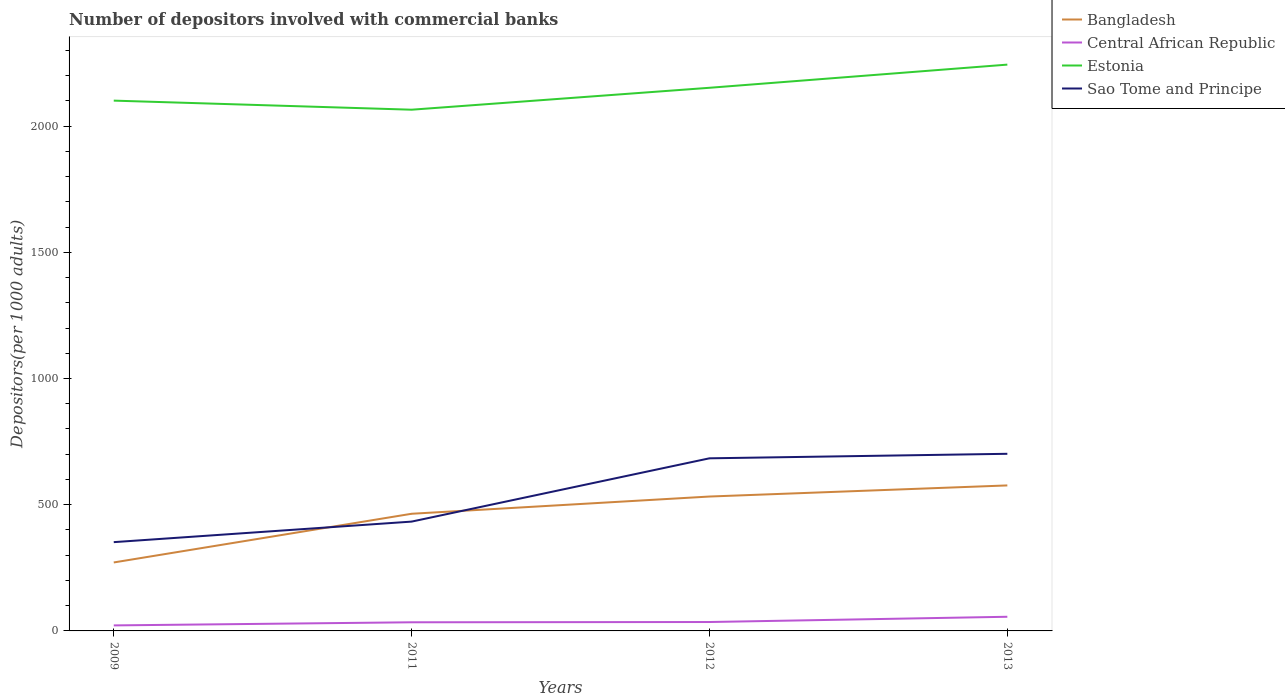How many different coloured lines are there?
Make the answer very short. 4. Does the line corresponding to Estonia intersect with the line corresponding to Bangladesh?
Provide a succinct answer. No. Is the number of lines equal to the number of legend labels?
Make the answer very short. Yes. Across all years, what is the maximum number of depositors involved with commercial banks in Central African Republic?
Your response must be concise. 21.85. In which year was the number of depositors involved with commercial banks in Estonia maximum?
Give a very brief answer. 2011. What is the total number of depositors involved with commercial banks in Bangladesh in the graph?
Offer a terse response. -43.98. What is the difference between the highest and the second highest number of depositors involved with commercial banks in Central African Republic?
Your answer should be very brief. 34.25. Is the number of depositors involved with commercial banks in Central African Republic strictly greater than the number of depositors involved with commercial banks in Sao Tome and Principe over the years?
Offer a very short reply. Yes. Does the graph contain any zero values?
Your answer should be very brief. No. Where does the legend appear in the graph?
Keep it short and to the point. Top right. What is the title of the graph?
Provide a short and direct response. Number of depositors involved with commercial banks. Does "Malta" appear as one of the legend labels in the graph?
Make the answer very short. No. What is the label or title of the X-axis?
Give a very brief answer. Years. What is the label or title of the Y-axis?
Keep it short and to the point. Depositors(per 1000 adults). What is the Depositors(per 1000 adults) in Bangladesh in 2009?
Give a very brief answer. 271.23. What is the Depositors(per 1000 adults) in Central African Republic in 2009?
Your answer should be very brief. 21.85. What is the Depositors(per 1000 adults) of Estonia in 2009?
Your answer should be compact. 2100.76. What is the Depositors(per 1000 adults) in Sao Tome and Principe in 2009?
Provide a short and direct response. 351.71. What is the Depositors(per 1000 adults) of Bangladesh in 2011?
Provide a short and direct response. 464.13. What is the Depositors(per 1000 adults) in Central African Republic in 2011?
Offer a terse response. 34.26. What is the Depositors(per 1000 adults) of Estonia in 2011?
Make the answer very short. 2064.84. What is the Depositors(per 1000 adults) in Sao Tome and Principe in 2011?
Ensure brevity in your answer.  433.08. What is the Depositors(per 1000 adults) in Bangladesh in 2012?
Make the answer very short. 532.4. What is the Depositors(per 1000 adults) of Central African Republic in 2012?
Give a very brief answer. 35.28. What is the Depositors(per 1000 adults) of Estonia in 2012?
Offer a very short reply. 2151.67. What is the Depositors(per 1000 adults) of Sao Tome and Principe in 2012?
Provide a short and direct response. 683.81. What is the Depositors(per 1000 adults) of Bangladesh in 2013?
Ensure brevity in your answer.  576.37. What is the Depositors(per 1000 adults) in Central African Republic in 2013?
Your answer should be very brief. 56.1. What is the Depositors(per 1000 adults) in Estonia in 2013?
Your response must be concise. 2243.44. What is the Depositors(per 1000 adults) of Sao Tome and Principe in 2013?
Provide a short and direct response. 701.7. Across all years, what is the maximum Depositors(per 1000 adults) of Bangladesh?
Provide a short and direct response. 576.37. Across all years, what is the maximum Depositors(per 1000 adults) in Central African Republic?
Your answer should be compact. 56.1. Across all years, what is the maximum Depositors(per 1000 adults) in Estonia?
Provide a succinct answer. 2243.44. Across all years, what is the maximum Depositors(per 1000 adults) in Sao Tome and Principe?
Your answer should be compact. 701.7. Across all years, what is the minimum Depositors(per 1000 adults) of Bangladesh?
Make the answer very short. 271.23. Across all years, what is the minimum Depositors(per 1000 adults) of Central African Republic?
Ensure brevity in your answer.  21.85. Across all years, what is the minimum Depositors(per 1000 adults) in Estonia?
Your answer should be compact. 2064.84. Across all years, what is the minimum Depositors(per 1000 adults) of Sao Tome and Principe?
Give a very brief answer. 351.71. What is the total Depositors(per 1000 adults) in Bangladesh in the graph?
Offer a very short reply. 1844.13. What is the total Depositors(per 1000 adults) in Central African Republic in the graph?
Ensure brevity in your answer.  147.48. What is the total Depositors(per 1000 adults) in Estonia in the graph?
Offer a very short reply. 8560.71. What is the total Depositors(per 1000 adults) of Sao Tome and Principe in the graph?
Your answer should be compact. 2170.3. What is the difference between the Depositors(per 1000 adults) in Bangladesh in 2009 and that in 2011?
Keep it short and to the point. -192.9. What is the difference between the Depositors(per 1000 adults) in Central African Republic in 2009 and that in 2011?
Offer a very short reply. -12.4. What is the difference between the Depositors(per 1000 adults) in Estonia in 2009 and that in 2011?
Offer a very short reply. 35.92. What is the difference between the Depositors(per 1000 adults) of Sao Tome and Principe in 2009 and that in 2011?
Offer a terse response. -81.37. What is the difference between the Depositors(per 1000 adults) of Bangladesh in 2009 and that in 2012?
Provide a succinct answer. -261.17. What is the difference between the Depositors(per 1000 adults) of Central African Republic in 2009 and that in 2012?
Your answer should be very brief. -13.43. What is the difference between the Depositors(per 1000 adults) in Estonia in 2009 and that in 2012?
Your answer should be very brief. -50.91. What is the difference between the Depositors(per 1000 adults) of Sao Tome and Principe in 2009 and that in 2012?
Give a very brief answer. -332.1. What is the difference between the Depositors(per 1000 adults) of Bangladesh in 2009 and that in 2013?
Offer a terse response. -305.15. What is the difference between the Depositors(per 1000 adults) in Central African Republic in 2009 and that in 2013?
Ensure brevity in your answer.  -34.25. What is the difference between the Depositors(per 1000 adults) in Estonia in 2009 and that in 2013?
Your response must be concise. -142.69. What is the difference between the Depositors(per 1000 adults) of Sao Tome and Principe in 2009 and that in 2013?
Provide a short and direct response. -349.99. What is the difference between the Depositors(per 1000 adults) of Bangladesh in 2011 and that in 2012?
Provide a short and direct response. -68.27. What is the difference between the Depositors(per 1000 adults) in Central African Republic in 2011 and that in 2012?
Your answer should be very brief. -1.02. What is the difference between the Depositors(per 1000 adults) in Estonia in 2011 and that in 2012?
Give a very brief answer. -86.83. What is the difference between the Depositors(per 1000 adults) of Sao Tome and Principe in 2011 and that in 2012?
Make the answer very short. -250.73. What is the difference between the Depositors(per 1000 adults) in Bangladesh in 2011 and that in 2013?
Keep it short and to the point. -112.24. What is the difference between the Depositors(per 1000 adults) of Central African Republic in 2011 and that in 2013?
Your answer should be compact. -21.84. What is the difference between the Depositors(per 1000 adults) of Estonia in 2011 and that in 2013?
Your response must be concise. -178.61. What is the difference between the Depositors(per 1000 adults) in Sao Tome and Principe in 2011 and that in 2013?
Make the answer very short. -268.62. What is the difference between the Depositors(per 1000 adults) of Bangladesh in 2012 and that in 2013?
Keep it short and to the point. -43.98. What is the difference between the Depositors(per 1000 adults) in Central African Republic in 2012 and that in 2013?
Provide a short and direct response. -20.82. What is the difference between the Depositors(per 1000 adults) of Estonia in 2012 and that in 2013?
Keep it short and to the point. -91.77. What is the difference between the Depositors(per 1000 adults) of Sao Tome and Principe in 2012 and that in 2013?
Provide a succinct answer. -17.89. What is the difference between the Depositors(per 1000 adults) of Bangladesh in 2009 and the Depositors(per 1000 adults) of Central African Republic in 2011?
Offer a very short reply. 236.97. What is the difference between the Depositors(per 1000 adults) of Bangladesh in 2009 and the Depositors(per 1000 adults) of Estonia in 2011?
Provide a succinct answer. -1793.61. What is the difference between the Depositors(per 1000 adults) in Bangladesh in 2009 and the Depositors(per 1000 adults) in Sao Tome and Principe in 2011?
Provide a short and direct response. -161.85. What is the difference between the Depositors(per 1000 adults) in Central African Republic in 2009 and the Depositors(per 1000 adults) in Estonia in 2011?
Give a very brief answer. -2042.99. What is the difference between the Depositors(per 1000 adults) of Central African Republic in 2009 and the Depositors(per 1000 adults) of Sao Tome and Principe in 2011?
Provide a succinct answer. -411.23. What is the difference between the Depositors(per 1000 adults) in Estonia in 2009 and the Depositors(per 1000 adults) in Sao Tome and Principe in 2011?
Provide a succinct answer. 1667.68. What is the difference between the Depositors(per 1000 adults) in Bangladesh in 2009 and the Depositors(per 1000 adults) in Central African Republic in 2012?
Your response must be concise. 235.95. What is the difference between the Depositors(per 1000 adults) of Bangladesh in 2009 and the Depositors(per 1000 adults) of Estonia in 2012?
Make the answer very short. -1880.44. What is the difference between the Depositors(per 1000 adults) in Bangladesh in 2009 and the Depositors(per 1000 adults) in Sao Tome and Principe in 2012?
Keep it short and to the point. -412.58. What is the difference between the Depositors(per 1000 adults) of Central African Republic in 2009 and the Depositors(per 1000 adults) of Estonia in 2012?
Give a very brief answer. -2129.82. What is the difference between the Depositors(per 1000 adults) of Central African Republic in 2009 and the Depositors(per 1000 adults) of Sao Tome and Principe in 2012?
Give a very brief answer. -661.96. What is the difference between the Depositors(per 1000 adults) of Estonia in 2009 and the Depositors(per 1000 adults) of Sao Tome and Principe in 2012?
Provide a short and direct response. 1416.95. What is the difference between the Depositors(per 1000 adults) of Bangladesh in 2009 and the Depositors(per 1000 adults) of Central African Republic in 2013?
Offer a very short reply. 215.13. What is the difference between the Depositors(per 1000 adults) in Bangladesh in 2009 and the Depositors(per 1000 adults) in Estonia in 2013?
Your response must be concise. -1972.22. What is the difference between the Depositors(per 1000 adults) in Bangladesh in 2009 and the Depositors(per 1000 adults) in Sao Tome and Principe in 2013?
Offer a very short reply. -430.47. What is the difference between the Depositors(per 1000 adults) in Central African Republic in 2009 and the Depositors(per 1000 adults) in Estonia in 2013?
Keep it short and to the point. -2221.59. What is the difference between the Depositors(per 1000 adults) of Central African Republic in 2009 and the Depositors(per 1000 adults) of Sao Tome and Principe in 2013?
Ensure brevity in your answer.  -679.85. What is the difference between the Depositors(per 1000 adults) in Estonia in 2009 and the Depositors(per 1000 adults) in Sao Tome and Principe in 2013?
Your answer should be compact. 1399.06. What is the difference between the Depositors(per 1000 adults) in Bangladesh in 2011 and the Depositors(per 1000 adults) in Central African Republic in 2012?
Provide a succinct answer. 428.85. What is the difference between the Depositors(per 1000 adults) of Bangladesh in 2011 and the Depositors(per 1000 adults) of Estonia in 2012?
Offer a very short reply. -1687.54. What is the difference between the Depositors(per 1000 adults) of Bangladesh in 2011 and the Depositors(per 1000 adults) of Sao Tome and Principe in 2012?
Your answer should be compact. -219.68. What is the difference between the Depositors(per 1000 adults) of Central African Republic in 2011 and the Depositors(per 1000 adults) of Estonia in 2012?
Your answer should be very brief. -2117.41. What is the difference between the Depositors(per 1000 adults) in Central African Republic in 2011 and the Depositors(per 1000 adults) in Sao Tome and Principe in 2012?
Give a very brief answer. -649.56. What is the difference between the Depositors(per 1000 adults) of Estonia in 2011 and the Depositors(per 1000 adults) of Sao Tome and Principe in 2012?
Your answer should be compact. 1381.02. What is the difference between the Depositors(per 1000 adults) in Bangladesh in 2011 and the Depositors(per 1000 adults) in Central African Republic in 2013?
Keep it short and to the point. 408.03. What is the difference between the Depositors(per 1000 adults) of Bangladesh in 2011 and the Depositors(per 1000 adults) of Estonia in 2013?
Offer a terse response. -1779.31. What is the difference between the Depositors(per 1000 adults) of Bangladesh in 2011 and the Depositors(per 1000 adults) of Sao Tome and Principe in 2013?
Give a very brief answer. -237.57. What is the difference between the Depositors(per 1000 adults) in Central African Republic in 2011 and the Depositors(per 1000 adults) in Estonia in 2013?
Offer a terse response. -2209.19. What is the difference between the Depositors(per 1000 adults) in Central African Republic in 2011 and the Depositors(per 1000 adults) in Sao Tome and Principe in 2013?
Make the answer very short. -667.44. What is the difference between the Depositors(per 1000 adults) of Estonia in 2011 and the Depositors(per 1000 adults) of Sao Tome and Principe in 2013?
Your response must be concise. 1363.14. What is the difference between the Depositors(per 1000 adults) in Bangladesh in 2012 and the Depositors(per 1000 adults) in Central African Republic in 2013?
Keep it short and to the point. 476.3. What is the difference between the Depositors(per 1000 adults) in Bangladesh in 2012 and the Depositors(per 1000 adults) in Estonia in 2013?
Provide a short and direct response. -1711.05. What is the difference between the Depositors(per 1000 adults) of Bangladesh in 2012 and the Depositors(per 1000 adults) of Sao Tome and Principe in 2013?
Keep it short and to the point. -169.3. What is the difference between the Depositors(per 1000 adults) in Central African Republic in 2012 and the Depositors(per 1000 adults) in Estonia in 2013?
Offer a very short reply. -2208.16. What is the difference between the Depositors(per 1000 adults) in Central African Republic in 2012 and the Depositors(per 1000 adults) in Sao Tome and Principe in 2013?
Your response must be concise. -666.42. What is the difference between the Depositors(per 1000 adults) of Estonia in 2012 and the Depositors(per 1000 adults) of Sao Tome and Principe in 2013?
Provide a succinct answer. 1449.97. What is the average Depositors(per 1000 adults) in Bangladesh per year?
Your response must be concise. 461.03. What is the average Depositors(per 1000 adults) in Central African Republic per year?
Your answer should be very brief. 36.87. What is the average Depositors(per 1000 adults) in Estonia per year?
Your answer should be compact. 2140.18. What is the average Depositors(per 1000 adults) of Sao Tome and Principe per year?
Your response must be concise. 542.58. In the year 2009, what is the difference between the Depositors(per 1000 adults) of Bangladesh and Depositors(per 1000 adults) of Central African Republic?
Offer a very short reply. 249.38. In the year 2009, what is the difference between the Depositors(per 1000 adults) of Bangladesh and Depositors(per 1000 adults) of Estonia?
Keep it short and to the point. -1829.53. In the year 2009, what is the difference between the Depositors(per 1000 adults) in Bangladesh and Depositors(per 1000 adults) in Sao Tome and Principe?
Your answer should be compact. -80.48. In the year 2009, what is the difference between the Depositors(per 1000 adults) of Central African Republic and Depositors(per 1000 adults) of Estonia?
Your response must be concise. -2078.91. In the year 2009, what is the difference between the Depositors(per 1000 adults) of Central African Republic and Depositors(per 1000 adults) of Sao Tome and Principe?
Give a very brief answer. -329.86. In the year 2009, what is the difference between the Depositors(per 1000 adults) in Estonia and Depositors(per 1000 adults) in Sao Tome and Principe?
Give a very brief answer. 1749.05. In the year 2011, what is the difference between the Depositors(per 1000 adults) in Bangladesh and Depositors(per 1000 adults) in Central African Republic?
Your answer should be very brief. 429.87. In the year 2011, what is the difference between the Depositors(per 1000 adults) in Bangladesh and Depositors(per 1000 adults) in Estonia?
Offer a very short reply. -1600.71. In the year 2011, what is the difference between the Depositors(per 1000 adults) in Bangladesh and Depositors(per 1000 adults) in Sao Tome and Principe?
Give a very brief answer. 31.05. In the year 2011, what is the difference between the Depositors(per 1000 adults) in Central African Republic and Depositors(per 1000 adults) in Estonia?
Make the answer very short. -2030.58. In the year 2011, what is the difference between the Depositors(per 1000 adults) in Central African Republic and Depositors(per 1000 adults) in Sao Tome and Principe?
Keep it short and to the point. -398.83. In the year 2011, what is the difference between the Depositors(per 1000 adults) in Estonia and Depositors(per 1000 adults) in Sao Tome and Principe?
Ensure brevity in your answer.  1631.76. In the year 2012, what is the difference between the Depositors(per 1000 adults) in Bangladesh and Depositors(per 1000 adults) in Central African Republic?
Offer a terse response. 497.12. In the year 2012, what is the difference between the Depositors(per 1000 adults) in Bangladesh and Depositors(per 1000 adults) in Estonia?
Your answer should be compact. -1619.27. In the year 2012, what is the difference between the Depositors(per 1000 adults) in Bangladesh and Depositors(per 1000 adults) in Sao Tome and Principe?
Give a very brief answer. -151.41. In the year 2012, what is the difference between the Depositors(per 1000 adults) in Central African Republic and Depositors(per 1000 adults) in Estonia?
Give a very brief answer. -2116.39. In the year 2012, what is the difference between the Depositors(per 1000 adults) in Central African Republic and Depositors(per 1000 adults) in Sao Tome and Principe?
Offer a very short reply. -648.53. In the year 2012, what is the difference between the Depositors(per 1000 adults) in Estonia and Depositors(per 1000 adults) in Sao Tome and Principe?
Make the answer very short. 1467.86. In the year 2013, what is the difference between the Depositors(per 1000 adults) of Bangladesh and Depositors(per 1000 adults) of Central African Republic?
Provide a short and direct response. 520.27. In the year 2013, what is the difference between the Depositors(per 1000 adults) in Bangladesh and Depositors(per 1000 adults) in Estonia?
Offer a terse response. -1667.07. In the year 2013, what is the difference between the Depositors(per 1000 adults) in Bangladesh and Depositors(per 1000 adults) in Sao Tome and Principe?
Give a very brief answer. -125.32. In the year 2013, what is the difference between the Depositors(per 1000 adults) in Central African Republic and Depositors(per 1000 adults) in Estonia?
Provide a short and direct response. -2187.34. In the year 2013, what is the difference between the Depositors(per 1000 adults) of Central African Republic and Depositors(per 1000 adults) of Sao Tome and Principe?
Your answer should be compact. -645.6. In the year 2013, what is the difference between the Depositors(per 1000 adults) in Estonia and Depositors(per 1000 adults) in Sao Tome and Principe?
Provide a short and direct response. 1541.75. What is the ratio of the Depositors(per 1000 adults) of Bangladesh in 2009 to that in 2011?
Make the answer very short. 0.58. What is the ratio of the Depositors(per 1000 adults) of Central African Republic in 2009 to that in 2011?
Your response must be concise. 0.64. What is the ratio of the Depositors(per 1000 adults) of Estonia in 2009 to that in 2011?
Ensure brevity in your answer.  1.02. What is the ratio of the Depositors(per 1000 adults) in Sao Tome and Principe in 2009 to that in 2011?
Your response must be concise. 0.81. What is the ratio of the Depositors(per 1000 adults) of Bangladesh in 2009 to that in 2012?
Offer a very short reply. 0.51. What is the ratio of the Depositors(per 1000 adults) of Central African Republic in 2009 to that in 2012?
Keep it short and to the point. 0.62. What is the ratio of the Depositors(per 1000 adults) in Estonia in 2009 to that in 2012?
Provide a succinct answer. 0.98. What is the ratio of the Depositors(per 1000 adults) of Sao Tome and Principe in 2009 to that in 2012?
Offer a terse response. 0.51. What is the ratio of the Depositors(per 1000 adults) of Bangladesh in 2009 to that in 2013?
Make the answer very short. 0.47. What is the ratio of the Depositors(per 1000 adults) of Central African Republic in 2009 to that in 2013?
Offer a terse response. 0.39. What is the ratio of the Depositors(per 1000 adults) in Estonia in 2009 to that in 2013?
Make the answer very short. 0.94. What is the ratio of the Depositors(per 1000 adults) of Sao Tome and Principe in 2009 to that in 2013?
Your answer should be compact. 0.5. What is the ratio of the Depositors(per 1000 adults) in Bangladesh in 2011 to that in 2012?
Keep it short and to the point. 0.87. What is the ratio of the Depositors(per 1000 adults) of Central African Republic in 2011 to that in 2012?
Ensure brevity in your answer.  0.97. What is the ratio of the Depositors(per 1000 adults) in Estonia in 2011 to that in 2012?
Your answer should be compact. 0.96. What is the ratio of the Depositors(per 1000 adults) of Sao Tome and Principe in 2011 to that in 2012?
Ensure brevity in your answer.  0.63. What is the ratio of the Depositors(per 1000 adults) in Bangladesh in 2011 to that in 2013?
Provide a succinct answer. 0.81. What is the ratio of the Depositors(per 1000 adults) in Central African Republic in 2011 to that in 2013?
Make the answer very short. 0.61. What is the ratio of the Depositors(per 1000 adults) in Estonia in 2011 to that in 2013?
Make the answer very short. 0.92. What is the ratio of the Depositors(per 1000 adults) of Sao Tome and Principe in 2011 to that in 2013?
Your answer should be very brief. 0.62. What is the ratio of the Depositors(per 1000 adults) in Bangladesh in 2012 to that in 2013?
Keep it short and to the point. 0.92. What is the ratio of the Depositors(per 1000 adults) in Central African Republic in 2012 to that in 2013?
Your response must be concise. 0.63. What is the ratio of the Depositors(per 1000 adults) in Estonia in 2012 to that in 2013?
Your answer should be compact. 0.96. What is the ratio of the Depositors(per 1000 adults) in Sao Tome and Principe in 2012 to that in 2013?
Your response must be concise. 0.97. What is the difference between the highest and the second highest Depositors(per 1000 adults) in Bangladesh?
Provide a succinct answer. 43.98. What is the difference between the highest and the second highest Depositors(per 1000 adults) of Central African Republic?
Provide a succinct answer. 20.82. What is the difference between the highest and the second highest Depositors(per 1000 adults) of Estonia?
Your answer should be compact. 91.77. What is the difference between the highest and the second highest Depositors(per 1000 adults) of Sao Tome and Principe?
Provide a short and direct response. 17.89. What is the difference between the highest and the lowest Depositors(per 1000 adults) in Bangladesh?
Provide a short and direct response. 305.15. What is the difference between the highest and the lowest Depositors(per 1000 adults) of Central African Republic?
Keep it short and to the point. 34.25. What is the difference between the highest and the lowest Depositors(per 1000 adults) of Estonia?
Your answer should be very brief. 178.61. What is the difference between the highest and the lowest Depositors(per 1000 adults) in Sao Tome and Principe?
Your answer should be very brief. 349.99. 